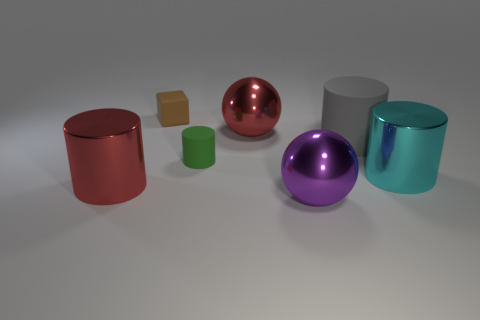What is the material of the large purple thing?
Your answer should be very brief. Metal. There is a green thing that is the same material as the gray cylinder; what shape is it?
Ensure brevity in your answer.  Cylinder. What is the size of the red object that is left of the metallic sphere left of the big purple shiny ball?
Make the answer very short. Large. There is a big metal sphere that is behind the large purple thing; what is its color?
Give a very brief answer. Red. Are there any small objects that have the same shape as the large cyan metal object?
Your response must be concise. Yes. Are there fewer shiny cylinders that are to the right of the tiny green rubber cylinder than objects in front of the gray matte thing?
Offer a terse response. Yes. What color is the large matte thing?
Ensure brevity in your answer.  Gray. Is there a small green matte object that is left of the matte object right of the big red ball?
Your answer should be compact. Yes. How many gray rubber cylinders are the same size as the green rubber thing?
Your answer should be compact. 0. There is a big cylinder left of the matte cylinder right of the large purple object; what number of things are behind it?
Your answer should be very brief. 5. 